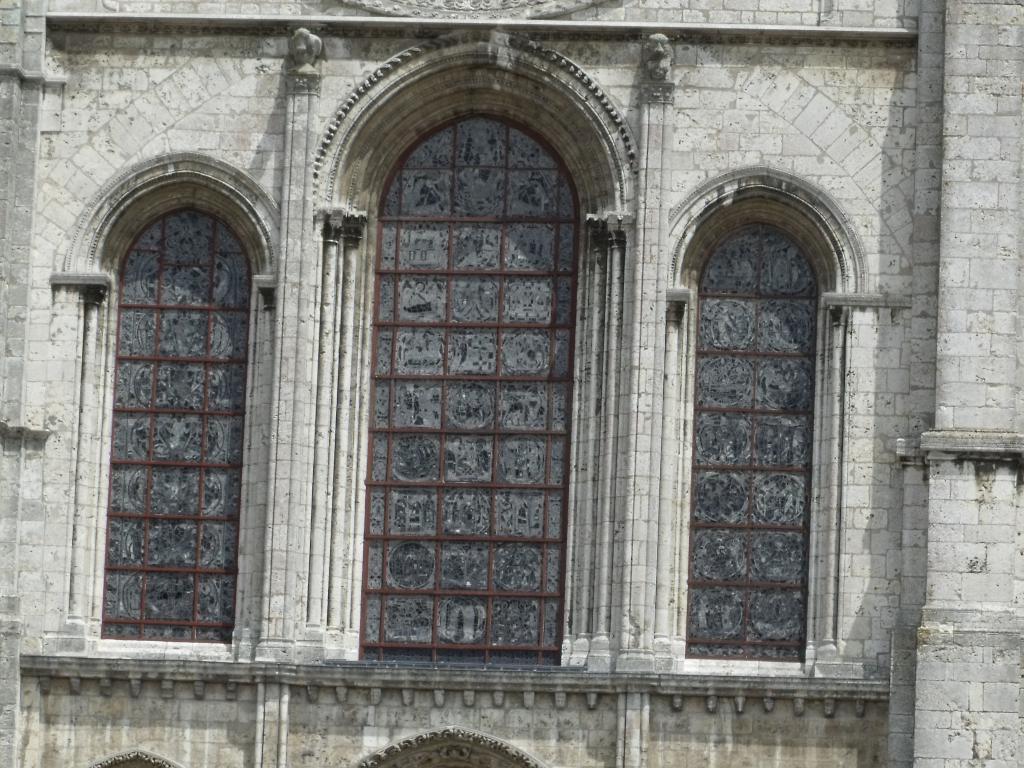How would you summarize this image in a sentence or two? In this image, we can see walls, glass objects and carvings. 